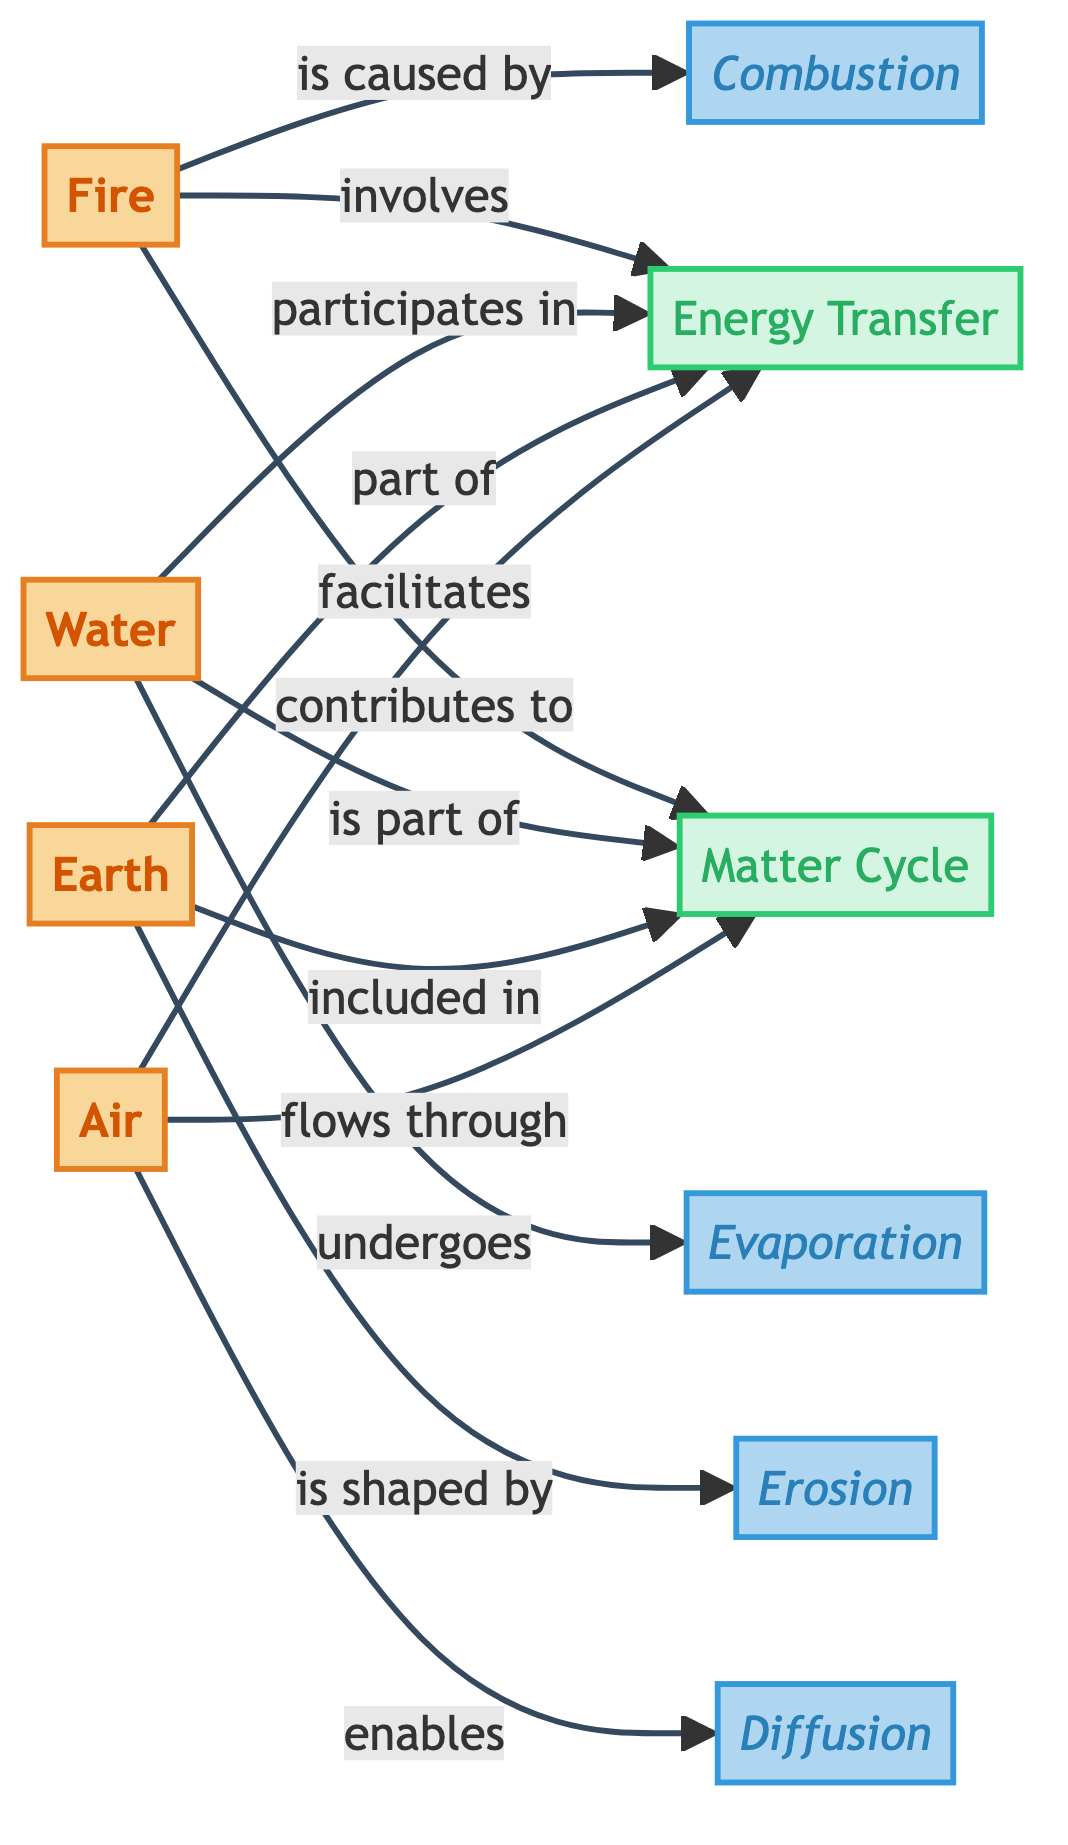What are the four elemental nodes present in the diagram? The diagram contains four elemental nodes: Fire, Water, Earth, and Air. These nodes are individually represented and distinctly labeled.
Answer: Fire, Water, Earth, Air How many processes are associated with the elemental nodes? There are four processes depicted in the diagram: Combustion, Evaporation, Erosion, and Diffusion. Each process describes how the elemental nodes interact and influence each other.
Answer: 4 Which element undergoes evaporation? According to the diagram, Water is the element that undergoes the process of evaporation. This relationship is directly shown through the labeled connection in the diagram.
Answer: Water What concept do all four elements contribute to? All four elements contribute to the concept of the Matter Cycle, as indicated by their directional arrows pointing towards this concept in the diagram.
Answer: Matter Cycle How is diffusion related to the air element in the diagram? The diagram shows that Air enables the process of Diffusion, establishing a direct relationship between the air element and its role in this particular process.
Answer: Enables What is the relationship between combustion and fire? The diagram clearly states that fire is caused by the process of combustion, which is indicated by the directed arrow from the fire node to the combustion process.
Answer: is caused by How do the elements participate in energy transfer? The diagram indicates that each of the four elements—fire, water, earth, and air—participates in the concept of Energy Transfer, as shown by their connections to this concept node.
Answer: Participates in Which process shapes the earth element? The earth element is shaped by the process referred to as Erosion, as depicted by the arrow pointing from the earth node to the erosion process in the diagram.
Answer: Erosion What are the four processes linked to the elemental nodes? The four processes linked to the elemental nodes, as visualized in the diagram, are Combustion, Evaporation, Erosion, and Diffusion. Each process corresponds to a particular interaction with an elemental node.
Answer: Combustion, Evaporation, Erosion, Diffusion How do the elements flow through the matter cycle? The diagram indicates that all elements—fire, water, earth, and air—are interconnected within the Matter Cycle, demonstrating their flow and participation in this cycle through directed relationships.
Answer: Flows through 